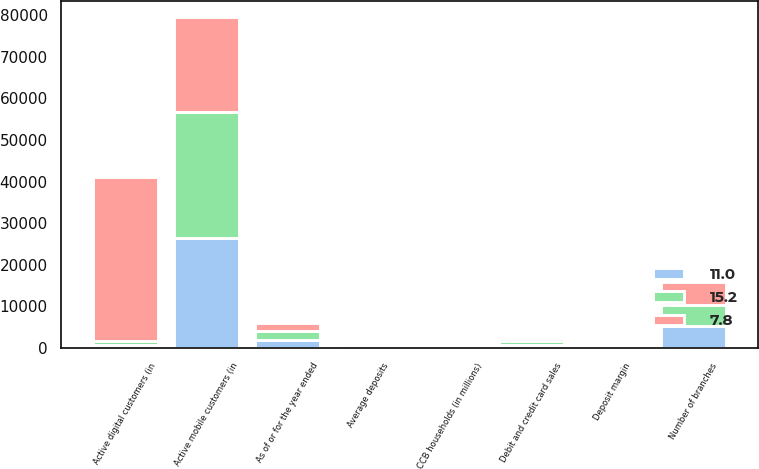Convert chart. <chart><loc_0><loc_0><loc_500><loc_500><stacked_bar_chart><ecel><fcel>As of or for the year ended<fcel>CCB households (in millions)<fcel>Number of branches<fcel>Active digital customers (in<fcel>Active mobile customers (in<fcel>Debit and credit card sales<fcel>Average deposits<fcel>Deposit margin<nl><fcel>15.2<fcel>2017<fcel>61<fcel>5130<fcel>869.25<fcel>30056<fcel>916.9<fcel>625.6<fcel>1.98<nl><fcel>11<fcel>2016<fcel>60.4<fcel>5258<fcel>869.25<fcel>26536<fcel>821.6<fcel>570.8<fcel>1.81<nl><fcel>7.8<fcel>2015<fcel>58.1<fcel>5413<fcel>39242<fcel>22810<fcel>754.1<fcel>515.2<fcel>1.9<nl></chart> 